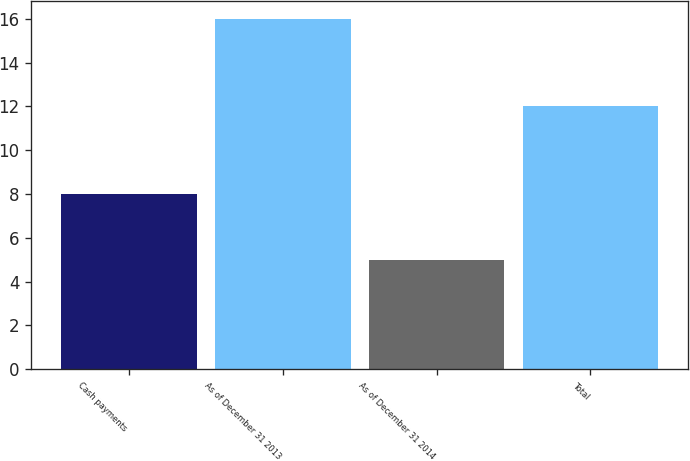Convert chart. <chart><loc_0><loc_0><loc_500><loc_500><bar_chart><fcel>Cash payments<fcel>As of December 31 2013<fcel>As of December 31 2014<fcel>Total<nl><fcel>8<fcel>16<fcel>5<fcel>12<nl></chart> 